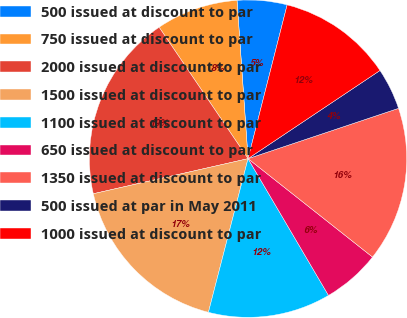<chart> <loc_0><loc_0><loc_500><loc_500><pie_chart><fcel>500 issued at discount to par<fcel>750 issued at discount to par<fcel>2000 issued at discount to par<fcel>1500 issued at discount to par<fcel>1100 issued at discount to par<fcel>650 issued at discount to par<fcel>1350 issued at discount to par<fcel>500 issued at par in May 2011<fcel>1000 issued at discount to par<nl><fcel>5.07%<fcel>8.36%<fcel>19.08%<fcel>17.43%<fcel>12.48%<fcel>5.89%<fcel>15.78%<fcel>4.24%<fcel>11.66%<nl></chart> 